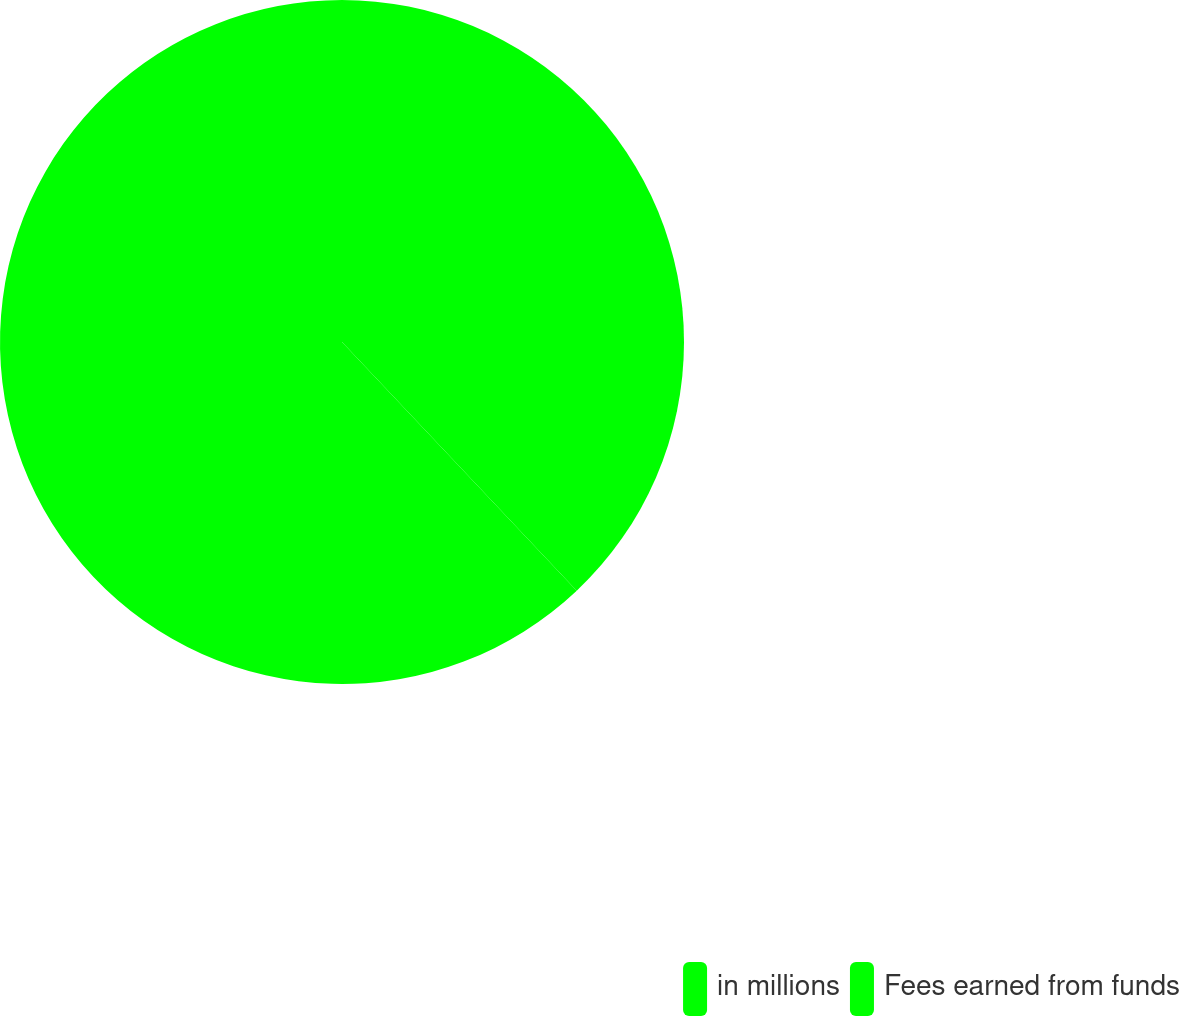<chart> <loc_0><loc_0><loc_500><loc_500><pie_chart><fcel>in millions<fcel>Fees earned from funds<nl><fcel>37.96%<fcel>62.04%<nl></chart> 